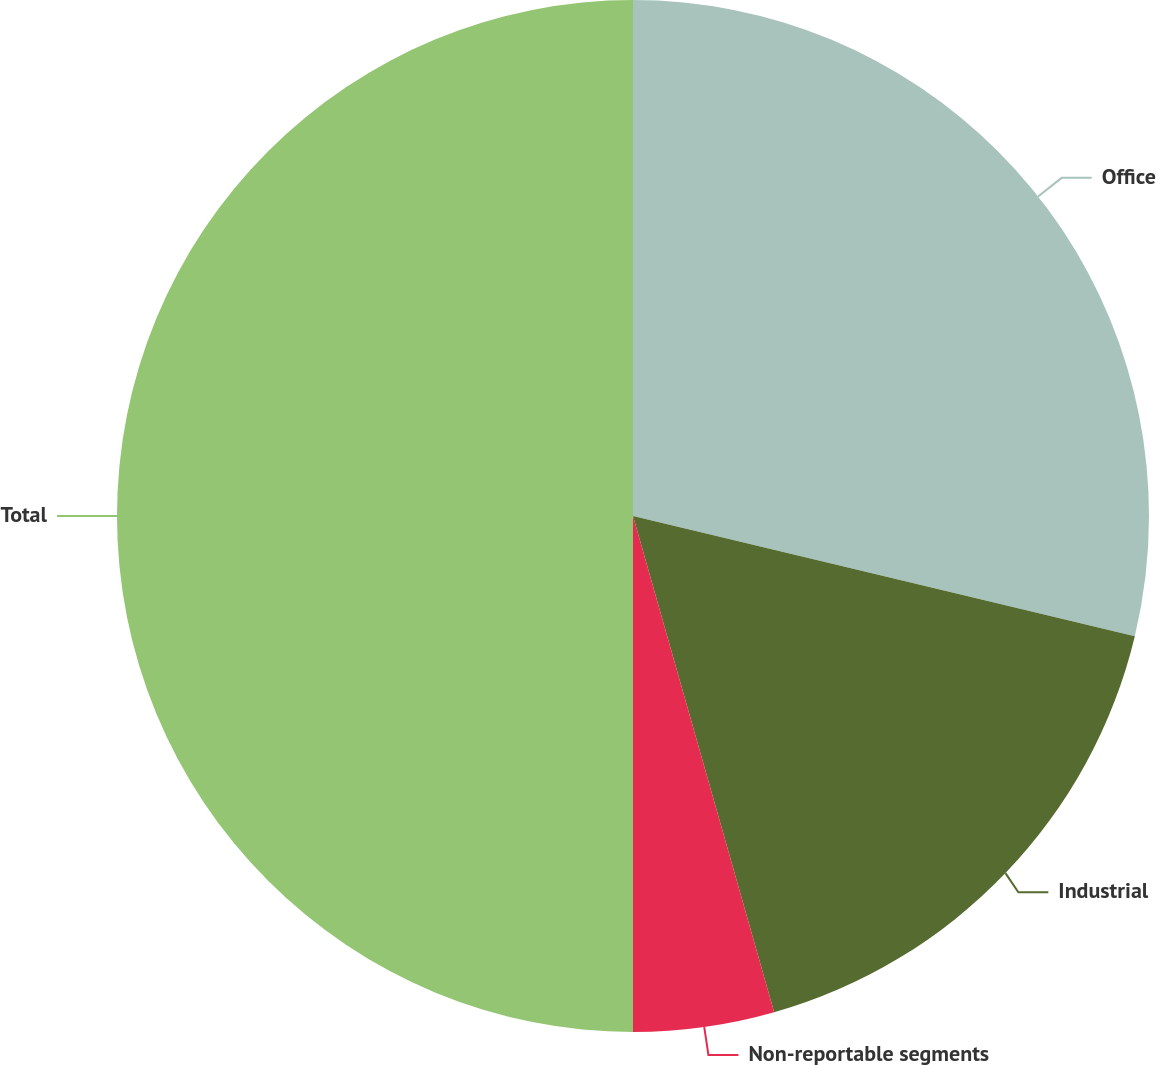<chart> <loc_0><loc_0><loc_500><loc_500><pie_chart><fcel>Office<fcel>Industrial<fcel>Non-reportable segments<fcel>Total<nl><fcel>28.74%<fcel>16.85%<fcel>4.41%<fcel>50.0%<nl></chart> 